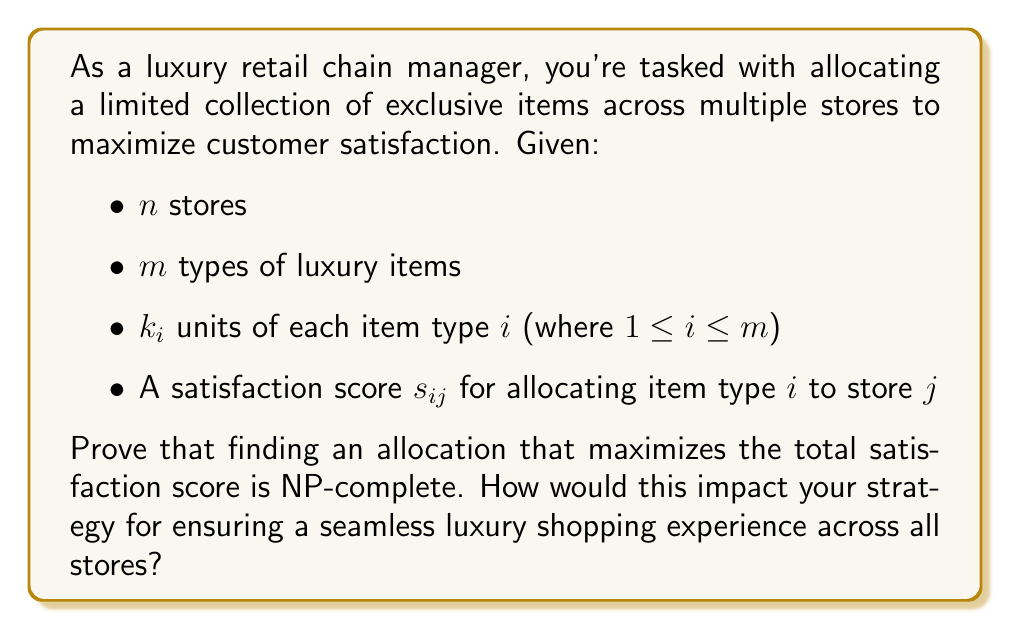What is the answer to this math problem? To prove that the luxury item allocation problem is NP-complete, we need to show that it is both in NP and NP-hard.

1. Prove the problem is in NP:
   A solution to this problem can be verified in polynomial time. Given an allocation, we can calculate the total satisfaction score by summing the individual scores for each item placed in each store. This can be done in $O(nm)$ time, which is polynomial.

2. Prove the problem is NP-hard:
   We can reduce the well-known NP-complete Partition problem to our luxury item allocation problem. The Partition problem asks whether a set of integers can be partitioned into two subsets with equal sums.

   Reduction:
   - Consider an instance of Partition with a set $S = \{a_1, a_2, ..., a_n\}$.
   - Create an instance of the luxury item allocation problem with:
     * 2 stores ($n = 2$)
     * $n$ types of luxury items ($m = n$)
     * 1 unit of each item type ($k_i = 1$ for all $i$)
     * Satisfaction scores: $s_{i1} = s_{i2} = a_i$ for all $i$

   The goal is to find an allocation with a total satisfaction score of exactly $\frac{1}{2}\sum_{i=1}^n a_i$.

   If there exists a solution to this luxury item allocation instance, it directly corresponds to a solution of the original Partition problem. Conversely, if there's a solution to the Partition problem, it can be translated into a solution for this luxury item allocation instance.

3. Conclusion:
   Since the problem is both in NP and NP-hard, it is NP-complete.

Impact on luxury shopping experience strategy:
1. Exact optimal solutions may be infeasible for large-scale operations.
2. Heuristic or approximation algorithms might be necessary for practical implementation.
3. Consider dividing the allocation problem into smaller, manageable sub-problems.
4. Implement a dynamic allocation system that can adjust to real-time demand and inventory levels.
5. Focus on maintaining a balanced inventory across stores to ensure a consistent luxury experience.
Answer: The luxury item allocation problem is NP-complete. This implies that finding an optimal allocation for a large number of stores and items is computationally intractable. Practical solutions may require approximation algorithms or heuristics to ensure efficient allocation while maintaining a high-quality shopping experience across all stores. 